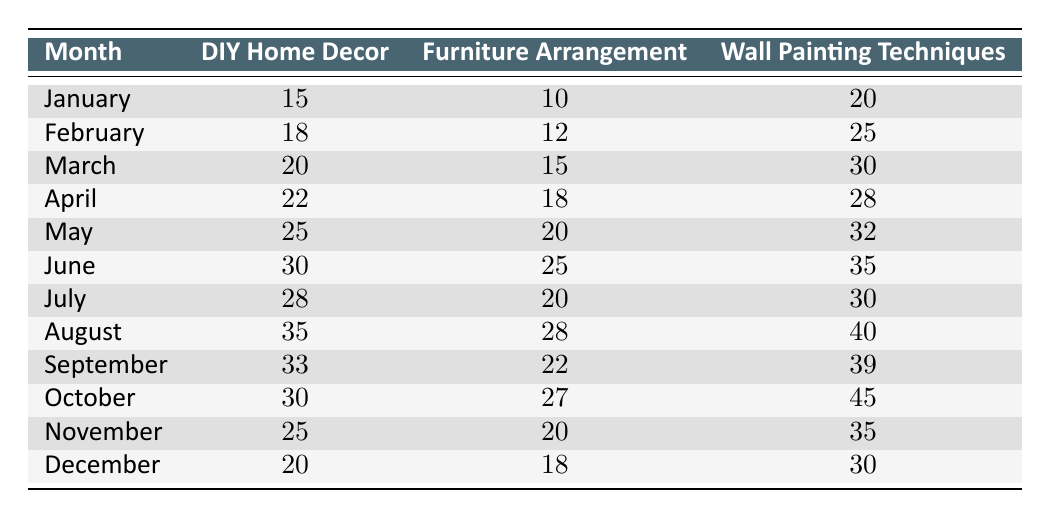What was the total attendance for Wall Painting Techniques in June? From the table, the attendance for Wall Painting Techniques in June is given as 35. Since this is a single value query, no calculations are needed.
Answer: 35 Which month had the highest attendance for DIY Home Decor? Looking through the table, the highest attendance for DIY Home Decor is in August, where it reached 35 attendees.
Answer: August How many more attendees were there for Wall Painting Techniques than Furniture Arrangement in October? In October, Wall Painting Techniques had 45 attendees and Furniture Arrangement had 27 attendees. The difference is 45 - 27 = 18.
Answer: 18 What is the average attendance for Furniture Arrangement across all months? To find the average for Furniture Arrangement, sum the attendance values: 10 + 12 + 15 + 18 + 20 + 25 + 20 + 28 + 22 + 27 + 20 + 18 =  219. There are 12 months, so the average is 219 / 12 = 18.25.
Answer: 18.25 In which month was the attendance for DIY Home Decor less than 25? By checking the table, the months where DIY Home Decor had less than 25 attendees are January (15), February (18), March (20), November (25), and December (20). Therefore, January, February, March, and December qualify; November does not qualify as it equals 25.
Answer: January, February, March, December Was there ever a month where the attendance for Wall Painting Techniques was 30 or below? Checking the table, the Wall Painting Techniques attendance was 20 (January), 25 (February), 30 (March), and below those values in subsequent months, confirming that there were instances where the attendance was 30 or below.
Answer: Yes What was the total attendance for all workshops in May? The total attendance for May can be calculated by adding all workshop attendees: 25 (DIY Home Decor) + 20 (Furniture Arrangement) + 32 (Wall Painting Techniques) = 77.
Answer: 77 What is the month with the second highest attendance for Furniture Arrangement? Based on the values, August has 28 attendees (highest) and October has 27 (second highest). Therefore, October is the second highest.
Answer: October 